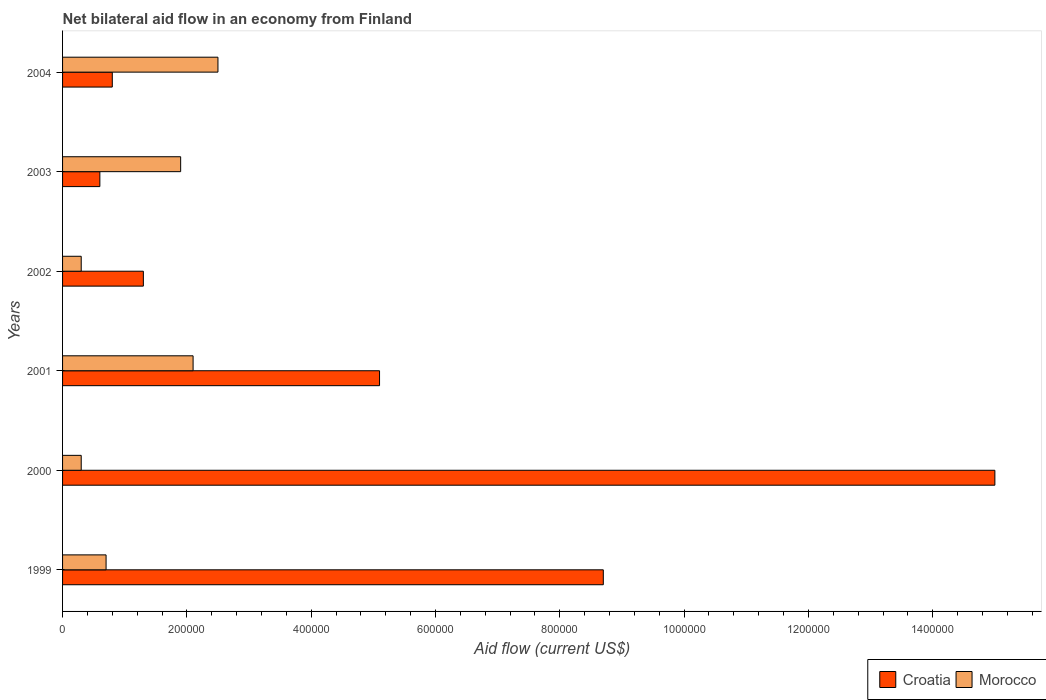How many different coloured bars are there?
Ensure brevity in your answer.  2. Are the number of bars per tick equal to the number of legend labels?
Provide a succinct answer. Yes. Are the number of bars on each tick of the Y-axis equal?
Provide a short and direct response. Yes. How many bars are there on the 2nd tick from the top?
Ensure brevity in your answer.  2. How many bars are there on the 3rd tick from the bottom?
Ensure brevity in your answer.  2. What is the label of the 2nd group of bars from the top?
Make the answer very short. 2003. In how many cases, is the number of bars for a given year not equal to the number of legend labels?
Your response must be concise. 0. What is the net bilateral aid flow in Morocco in 2003?
Offer a terse response. 1.90e+05. In which year was the net bilateral aid flow in Croatia maximum?
Give a very brief answer. 2000. What is the total net bilateral aid flow in Morocco in the graph?
Give a very brief answer. 7.80e+05. What is the difference between the net bilateral aid flow in Morocco in 2000 and the net bilateral aid flow in Croatia in 1999?
Offer a very short reply. -8.40e+05. What is the average net bilateral aid flow in Croatia per year?
Your response must be concise. 5.25e+05. In the year 2002, what is the difference between the net bilateral aid flow in Croatia and net bilateral aid flow in Morocco?
Make the answer very short. 1.00e+05. In how many years, is the net bilateral aid flow in Croatia greater than 320000 US$?
Provide a short and direct response. 3. What is the ratio of the net bilateral aid flow in Morocco in 1999 to that in 2004?
Offer a very short reply. 0.28. Is the net bilateral aid flow in Morocco in 1999 less than that in 2001?
Offer a very short reply. Yes. Is the difference between the net bilateral aid flow in Croatia in 1999 and 2004 greater than the difference between the net bilateral aid flow in Morocco in 1999 and 2004?
Make the answer very short. Yes. What is the difference between the highest and the second highest net bilateral aid flow in Croatia?
Keep it short and to the point. 6.30e+05. What is the difference between the highest and the lowest net bilateral aid flow in Croatia?
Your response must be concise. 1.44e+06. Is the sum of the net bilateral aid flow in Morocco in 2002 and 2003 greater than the maximum net bilateral aid flow in Croatia across all years?
Ensure brevity in your answer.  No. What does the 2nd bar from the top in 2004 represents?
Your response must be concise. Croatia. What does the 1st bar from the bottom in 2004 represents?
Provide a succinct answer. Croatia. Are the values on the major ticks of X-axis written in scientific E-notation?
Provide a short and direct response. No. Does the graph contain any zero values?
Your answer should be very brief. No. Does the graph contain grids?
Provide a short and direct response. No. What is the title of the graph?
Make the answer very short. Net bilateral aid flow in an economy from Finland. Does "Small states" appear as one of the legend labels in the graph?
Provide a short and direct response. No. What is the label or title of the X-axis?
Your answer should be compact. Aid flow (current US$). What is the Aid flow (current US$) of Croatia in 1999?
Offer a very short reply. 8.70e+05. What is the Aid flow (current US$) of Croatia in 2000?
Ensure brevity in your answer.  1.50e+06. What is the Aid flow (current US$) in Morocco in 2000?
Offer a very short reply. 3.00e+04. What is the Aid flow (current US$) of Croatia in 2001?
Offer a terse response. 5.10e+05. What is the Aid flow (current US$) in Morocco in 2001?
Your answer should be compact. 2.10e+05. What is the Aid flow (current US$) in Croatia in 2002?
Make the answer very short. 1.30e+05. What is the Aid flow (current US$) of Croatia in 2004?
Ensure brevity in your answer.  8.00e+04. Across all years, what is the maximum Aid flow (current US$) of Croatia?
Your answer should be very brief. 1.50e+06. Across all years, what is the maximum Aid flow (current US$) of Morocco?
Your answer should be very brief. 2.50e+05. What is the total Aid flow (current US$) in Croatia in the graph?
Ensure brevity in your answer.  3.15e+06. What is the total Aid flow (current US$) of Morocco in the graph?
Offer a terse response. 7.80e+05. What is the difference between the Aid flow (current US$) in Croatia in 1999 and that in 2000?
Your response must be concise. -6.30e+05. What is the difference between the Aid flow (current US$) in Croatia in 1999 and that in 2001?
Give a very brief answer. 3.60e+05. What is the difference between the Aid flow (current US$) in Croatia in 1999 and that in 2002?
Offer a terse response. 7.40e+05. What is the difference between the Aid flow (current US$) in Croatia in 1999 and that in 2003?
Offer a terse response. 8.10e+05. What is the difference between the Aid flow (current US$) in Croatia in 1999 and that in 2004?
Make the answer very short. 7.90e+05. What is the difference between the Aid flow (current US$) in Croatia in 2000 and that in 2001?
Your answer should be very brief. 9.90e+05. What is the difference between the Aid flow (current US$) in Croatia in 2000 and that in 2002?
Offer a very short reply. 1.37e+06. What is the difference between the Aid flow (current US$) in Croatia in 2000 and that in 2003?
Give a very brief answer. 1.44e+06. What is the difference between the Aid flow (current US$) of Croatia in 2000 and that in 2004?
Offer a terse response. 1.42e+06. What is the difference between the Aid flow (current US$) of Croatia in 2001 and that in 2002?
Your answer should be compact. 3.80e+05. What is the difference between the Aid flow (current US$) in Croatia in 2001 and that in 2003?
Provide a short and direct response. 4.50e+05. What is the difference between the Aid flow (current US$) of Morocco in 2001 and that in 2003?
Your answer should be compact. 2.00e+04. What is the difference between the Aid flow (current US$) of Morocco in 2001 and that in 2004?
Make the answer very short. -4.00e+04. What is the difference between the Aid flow (current US$) in Croatia in 2002 and that in 2004?
Your response must be concise. 5.00e+04. What is the difference between the Aid flow (current US$) in Morocco in 2002 and that in 2004?
Keep it short and to the point. -2.20e+05. What is the difference between the Aid flow (current US$) of Croatia in 1999 and the Aid flow (current US$) of Morocco in 2000?
Offer a very short reply. 8.40e+05. What is the difference between the Aid flow (current US$) of Croatia in 1999 and the Aid flow (current US$) of Morocco in 2001?
Keep it short and to the point. 6.60e+05. What is the difference between the Aid flow (current US$) in Croatia in 1999 and the Aid flow (current US$) in Morocco in 2002?
Offer a terse response. 8.40e+05. What is the difference between the Aid flow (current US$) in Croatia in 1999 and the Aid flow (current US$) in Morocco in 2003?
Make the answer very short. 6.80e+05. What is the difference between the Aid flow (current US$) of Croatia in 1999 and the Aid flow (current US$) of Morocco in 2004?
Provide a short and direct response. 6.20e+05. What is the difference between the Aid flow (current US$) of Croatia in 2000 and the Aid flow (current US$) of Morocco in 2001?
Provide a short and direct response. 1.29e+06. What is the difference between the Aid flow (current US$) of Croatia in 2000 and the Aid flow (current US$) of Morocco in 2002?
Your answer should be compact. 1.47e+06. What is the difference between the Aid flow (current US$) in Croatia in 2000 and the Aid flow (current US$) in Morocco in 2003?
Your response must be concise. 1.31e+06. What is the difference between the Aid flow (current US$) in Croatia in 2000 and the Aid flow (current US$) in Morocco in 2004?
Ensure brevity in your answer.  1.25e+06. What is the difference between the Aid flow (current US$) of Croatia in 2002 and the Aid flow (current US$) of Morocco in 2003?
Provide a succinct answer. -6.00e+04. What is the difference between the Aid flow (current US$) of Croatia in 2002 and the Aid flow (current US$) of Morocco in 2004?
Provide a short and direct response. -1.20e+05. What is the average Aid flow (current US$) in Croatia per year?
Provide a short and direct response. 5.25e+05. What is the average Aid flow (current US$) in Morocco per year?
Make the answer very short. 1.30e+05. In the year 1999, what is the difference between the Aid flow (current US$) in Croatia and Aid flow (current US$) in Morocco?
Offer a very short reply. 8.00e+05. In the year 2000, what is the difference between the Aid flow (current US$) of Croatia and Aid flow (current US$) of Morocco?
Ensure brevity in your answer.  1.47e+06. In the year 2003, what is the difference between the Aid flow (current US$) of Croatia and Aid flow (current US$) of Morocco?
Provide a short and direct response. -1.30e+05. In the year 2004, what is the difference between the Aid flow (current US$) in Croatia and Aid flow (current US$) in Morocco?
Give a very brief answer. -1.70e+05. What is the ratio of the Aid flow (current US$) of Croatia in 1999 to that in 2000?
Your answer should be very brief. 0.58. What is the ratio of the Aid flow (current US$) of Morocco in 1999 to that in 2000?
Provide a succinct answer. 2.33. What is the ratio of the Aid flow (current US$) in Croatia in 1999 to that in 2001?
Keep it short and to the point. 1.71. What is the ratio of the Aid flow (current US$) of Croatia in 1999 to that in 2002?
Offer a very short reply. 6.69. What is the ratio of the Aid flow (current US$) in Morocco in 1999 to that in 2002?
Give a very brief answer. 2.33. What is the ratio of the Aid flow (current US$) of Morocco in 1999 to that in 2003?
Your response must be concise. 0.37. What is the ratio of the Aid flow (current US$) in Croatia in 1999 to that in 2004?
Make the answer very short. 10.88. What is the ratio of the Aid flow (current US$) in Morocco in 1999 to that in 2004?
Make the answer very short. 0.28. What is the ratio of the Aid flow (current US$) of Croatia in 2000 to that in 2001?
Offer a very short reply. 2.94. What is the ratio of the Aid flow (current US$) of Morocco in 2000 to that in 2001?
Keep it short and to the point. 0.14. What is the ratio of the Aid flow (current US$) in Croatia in 2000 to that in 2002?
Your answer should be very brief. 11.54. What is the ratio of the Aid flow (current US$) in Morocco in 2000 to that in 2003?
Offer a very short reply. 0.16. What is the ratio of the Aid flow (current US$) in Croatia in 2000 to that in 2004?
Offer a very short reply. 18.75. What is the ratio of the Aid flow (current US$) in Morocco in 2000 to that in 2004?
Offer a terse response. 0.12. What is the ratio of the Aid flow (current US$) of Croatia in 2001 to that in 2002?
Keep it short and to the point. 3.92. What is the ratio of the Aid flow (current US$) of Morocco in 2001 to that in 2002?
Your answer should be very brief. 7. What is the ratio of the Aid flow (current US$) of Croatia in 2001 to that in 2003?
Your response must be concise. 8.5. What is the ratio of the Aid flow (current US$) in Morocco in 2001 to that in 2003?
Offer a terse response. 1.11. What is the ratio of the Aid flow (current US$) of Croatia in 2001 to that in 2004?
Offer a very short reply. 6.38. What is the ratio of the Aid flow (current US$) of Morocco in 2001 to that in 2004?
Provide a succinct answer. 0.84. What is the ratio of the Aid flow (current US$) in Croatia in 2002 to that in 2003?
Provide a succinct answer. 2.17. What is the ratio of the Aid flow (current US$) in Morocco in 2002 to that in 2003?
Make the answer very short. 0.16. What is the ratio of the Aid flow (current US$) in Croatia in 2002 to that in 2004?
Keep it short and to the point. 1.62. What is the ratio of the Aid flow (current US$) in Morocco in 2002 to that in 2004?
Ensure brevity in your answer.  0.12. What is the ratio of the Aid flow (current US$) in Morocco in 2003 to that in 2004?
Give a very brief answer. 0.76. What is the difference between the highest and the second highest Aid flow (current US$) of Croatia?
Your answer should be very brief. 6.30e+05. What is the difference between the highest and the second highest Aid flow (current US$) of Morocco?
Your answer should be compact. 4.00e+04. What is the difference between the highest and the lowest Aid flow (current US$) in Croatia?
Offer a very short reply. 1.44e+06. 